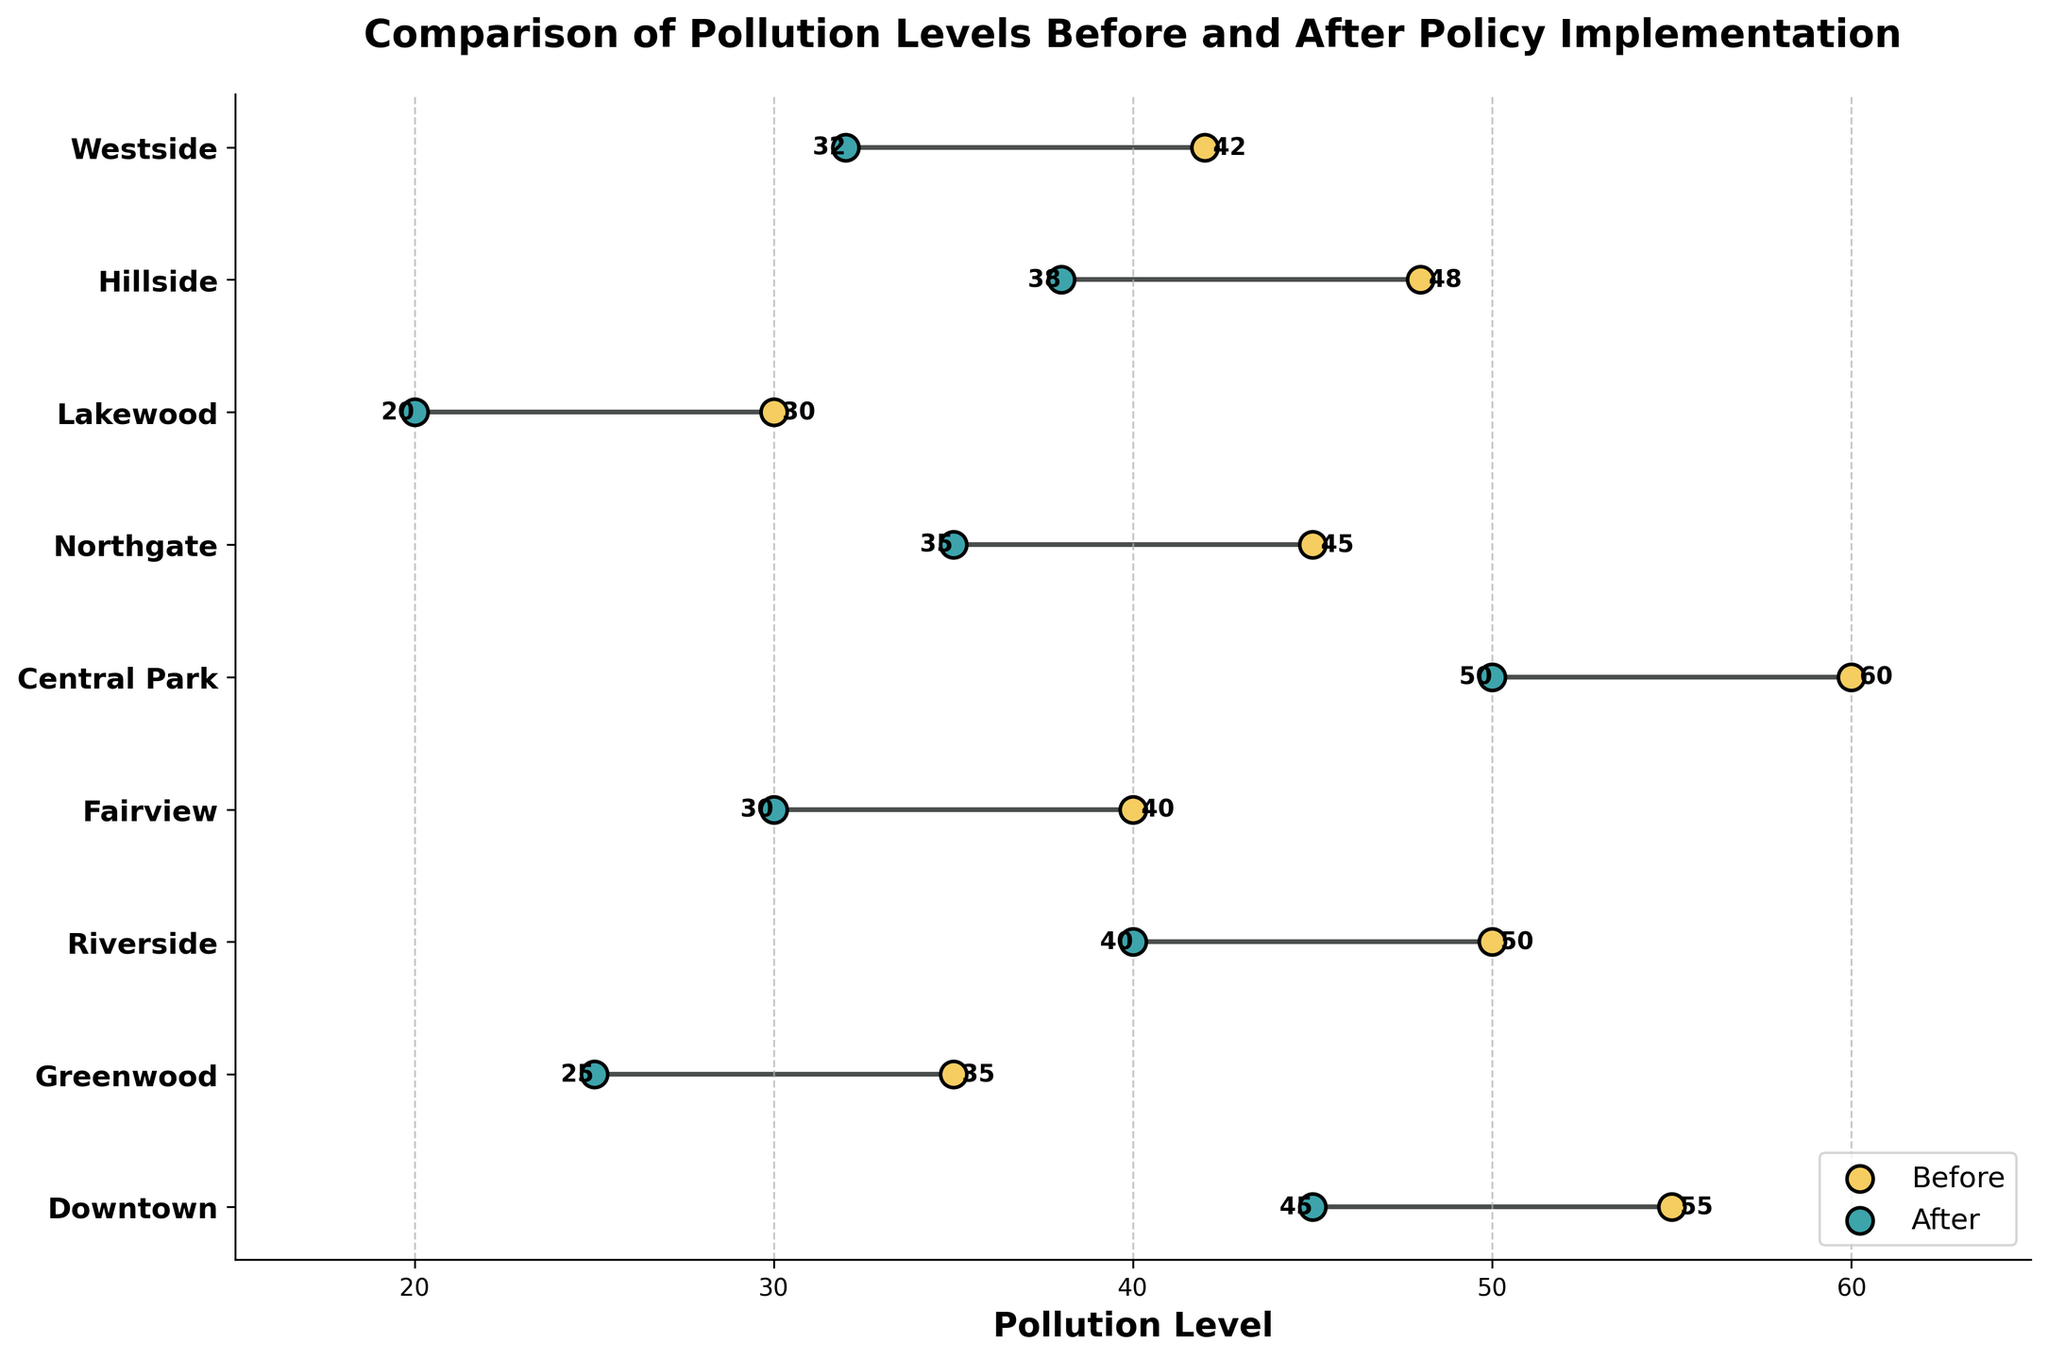What's the title of the plot? The title is typically located at the top of the plot. It provides a summary of the plot's content. In this case, the title reads "Comparison of Pollution Levels Before and After Policy Implementation".
Answer: Comparison of Pollution Levels Before and After Policy Implementation What is the pollution level in Downtown before the policy implementation? Locate the "Downtown" neighborhood on the y-axis and follow the line to the value on the x-axis that corresponds to "Before". The value at this point is 55.
Answer: 55 Which neighborhood has the largest reduction in pollution levels? To find this, calculate the difference between the "Before" and "After" pollution levels for each neighborhood. Downtown: 55-45=10, Greenwood: 35-25=10, Riverside: 50-40=10, Fairview: 40-30=10, Central Park: 60-50=10, Northgate: 45-35=10, Lakewood: 30-20=10, Hillside: 48-38=10, Westside: 42-32=10. All neighborhoods have the same reduction of 10 units.
Answer: All neighborhoods (10 units reduction) Which neighborhood had the highest pollution level before the policy was implemented? Look at the "Before" pollution levels and identify the highest value. The highest value is associated with "Central Park" at 60.
Answer: Central Park What is the difference in pollution levels in Riverside before and after policy implementation? Identify Riverside's pollution levels before and after policy implementation from the plot, then subtract the "After" value from the "Before" value. Before: 50, After: 40. The difference is 50-40.
Answer: 10 Which neighborhood has the lowest pollution level after the policy implementation? Look at the "After" pollution levels and identify the lowest value. The lowest value is associated with "Lakewood" at 20.
Answer: Lakewood What's the average pollution reduction across all neighborhoods? Calculate the pollution reduction for each neighborhood: Downtown: 10, Greenwood: 10, Riverside: 10, Fairview: 10, Central Park: 10, Northgate: 10, Lakewood: 10, Hillside: 10, Westside: 10. The average reduction is the sum of reductions divided by the number of neighborhoods: (10+10+10+10+10+10+10+10+10)/9 = 10.
Answer: 10 How many neighborhoods had pollution levels above 40 before the policy implementation? Count the number of neighborhoods with "Before" pollution levels greater than 40. Downtown: 55, Riverside: 50, Central Park: 60, Northgate: 45, Hillside: 48. There are 5 such neighborhoods.
Answer: 5 Is there any neighborhood where the pollution level remained unchanged after the policy implementation? Check the "Before" and "After" values for each neighborhood to see if they are the same. In every case, the "After" pollution level is lower than the "Before" level.
Answer: No Which two neighborhoods have the same pollution reduction, and what is that value? Calculate the pollution reduction for each neighborhood. All neighborhoods have a reduction of 10 units. Therefore, any pair of neighborhoods could be selected, e.g., Downtown and Greenwood.
Answer: Downtown and Greenwood, 10 